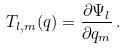<formula> <loc_0><loc_0><loc_500><loc_500>T _ { l , m } ( { q } ) = \frac { \partial \Psi _ { l } } { \partial q _ { m } } \, .</formula> 